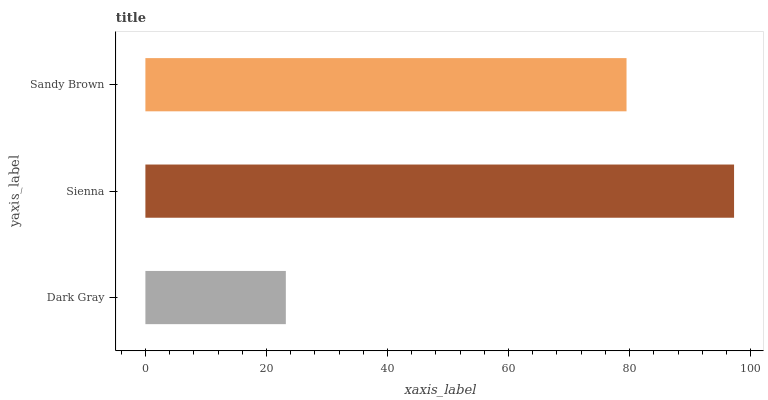Is Dark Gray the minimum?
Answer yes or no. Yes. Is Sienna the maximum?
Answer yes or no. Yes. Is Sandy Brown the minimum?
Answer yes or no. No. Is Sandy Brown the maximum?
Answer yes or no. No. Is Sienna greater than Sandy Brown?
Answer yes or no. Yes. Is Sandy Brown less than Sienna?
Answer yes or no. Yes. Is Sandy Brown greater than Sienna?
Answer yes or no. No. Is Sienna less than Sandy Brown?
Answer yes or no. No. Is Sandy Brown the high median?
Answer yes or no. Yes. Is Sandy Brown the low median?
Answer yes or no. Yes. Is Dark Gray the high median?
Answer yes or no. No. Is Sienna the low median?
Answer yes or no. No. 